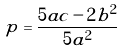Convert formula to latex. <formula><loc_0><loc_0><loc_500><loc_500>p = \frac { 5 a c - 2 b ^ { 2 } } { 5 a ^ { 2 } }</formula> 